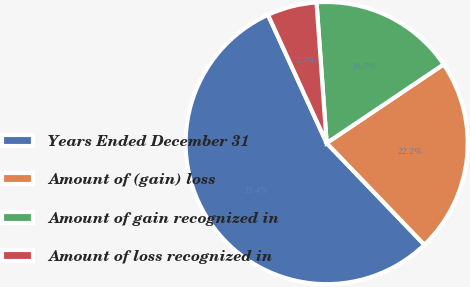<chart> <loc_0><loc_0><loc_500><loc_500><pie_chart><fcel>Years Ended December 31<fcel>Amount of (gain) loss<fcel>Amount of gain recognized in<fcel>Amount of loss recognized in<nl><fcel>55.35%<fcel>22.24%<fcel>16.72%<fcel>5.68%<nl></chart> 